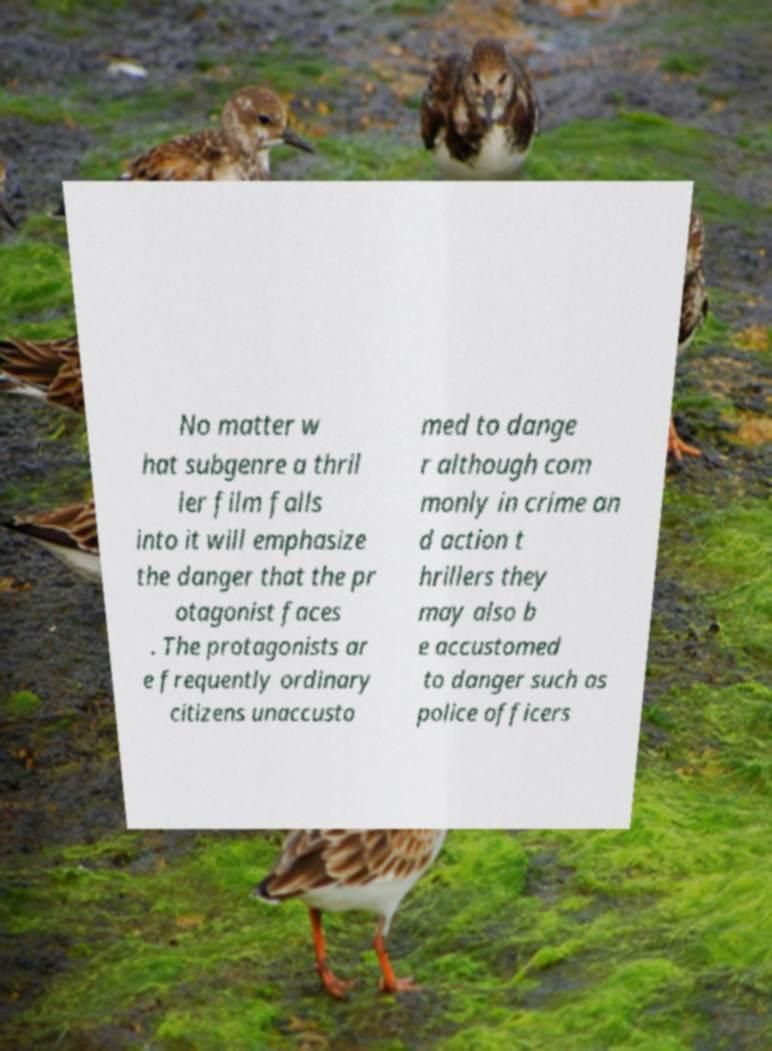Please read and relay the text visible in this image. What does it say? No matter w hat subgenre a thril ler film falls into it will emphasize the danger that the pr otagonist faces . The protagonists ar e frequently ordinary citizens unaccusto med to dange r although com monly in crime an d action t hrillers they may also b e accustomed to danger such as police officers 